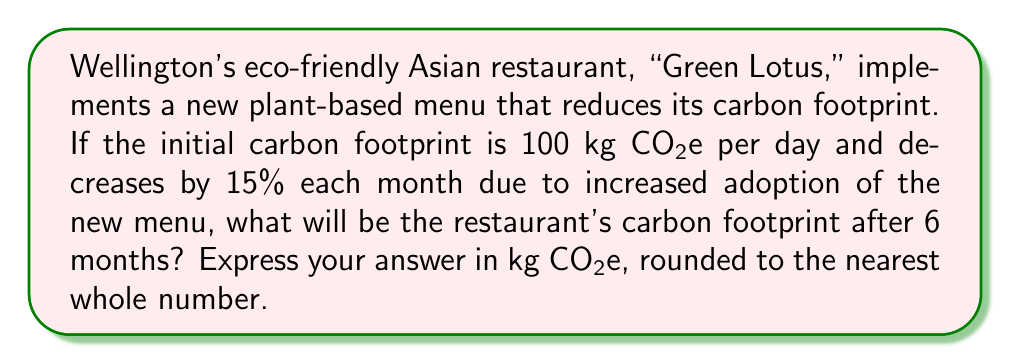Can you solve this math problem? To solve this problem, we'll use the exponential decay model:

$A = A_0 \cdot (1-r)^t$

Where:
$A$ = Final amount
$A_0$ = Initial amount
$r$ = Rate of decay (as a decimal)
$t$ = Time periods

Given:
$A_0 = 100$ kg CO₂e
$r = 15\% = 0.15$
$t = 6$ months

Step 1: Plug the values into the formula
$$A = 100 \cdot (1-0.15)^6$$

Step 2: Simplify the base of the exponent
$$A = 100 \cdot (0.85)^6$$

Step 3: Calculate the exponent
$$A = 100 \cdot 0.377628$$

Step 4: Multiply
$$A = 37.7628$$ kg CO₂e

Step 5: Round to the nearest whole number
$$A \approx 38$$ kg CO₂e
Answer: 38 kg CO₂e 